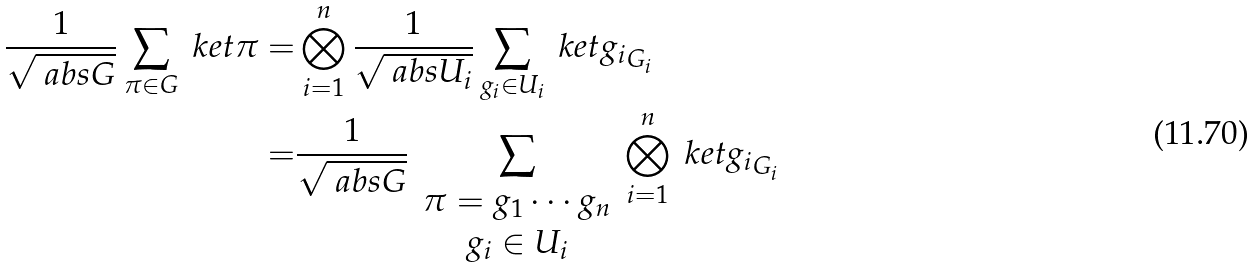Convert formula to latex. <formula><loc_0><loc_0><loc_500><loc_500>\frac { 1 } { \sqrt { \ a b s { G } } } \sum _ { \pi \in G } \ k e t { \pi } = & \bigotimes _ { i = 1 } ^ { n } \frac { 1 } { \sqrt { \ a b s { U _ { i } } } } \sum _ { g _ { i } \in U _ { i } } \ k e t { g _ { i } } _ { G _ { i } } \\ = & \frac { 1 } { \sqrt { \ a b s { G } } } \sum _ { \begin{array} { c } \pi = g _ { 1 } \cdots g _ { n } \\ g _ { i } \in U _ { i } \end{array} } \bigotimes _ { i = 1 } ^ { n } \ k e t { g _ { i } } _ { G _ { i } }</formula> 